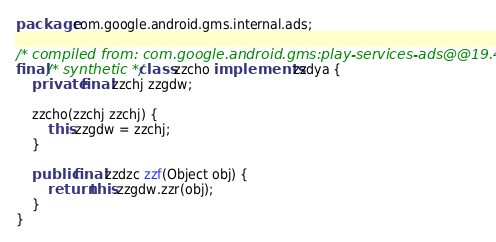Convert code to text. <code><loc_0><loc_0><loc_500><loc_500><_Java_>package com.google.android.gms.internal.ads;

/* compiled from: com.google.android.gms:play-services-ads@@19.4.0 */
final /* synthetic */ class zzcho implements zzdya {
    private final zzchj zzgdw;

    zzcho(zzchj zzchj) {
        this.zzgdw = zzchj;
    }

    public final zzdzc zzf(Object obj) {
        return this.zzgdw.zzr(obj);
    }
}
</code> 